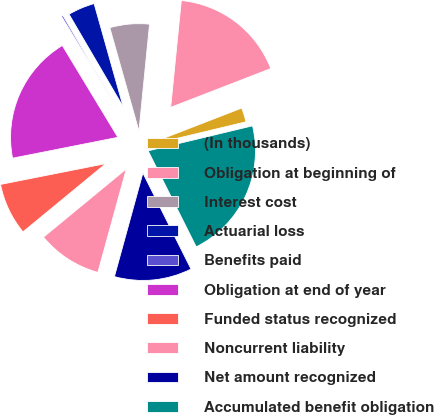Convert chart. <chart><loc_0><loc_0><loc_500><loc_500><pie_chart><fcel>(In thousands)<fcel>Obligation at beginning of<fcel>Interest cost<fcel>Actuarial loss<fcel>Benefits paid<fcel>Obligation at end of year<fcel>Funded status recognized<fcel>Noncurrent liability<fcel>Net amount recognized<fcel>Accumulated benefit obligation<nl><fcel>2.14%<fcel>17.54%<fcel>5.95%<fcel>4.05%<fcel>0.24%<fcel>19.45%<fcel>7.86%<fcel>9.76%<fcel>11.67%<fcel>21.35%<nl></chart> 